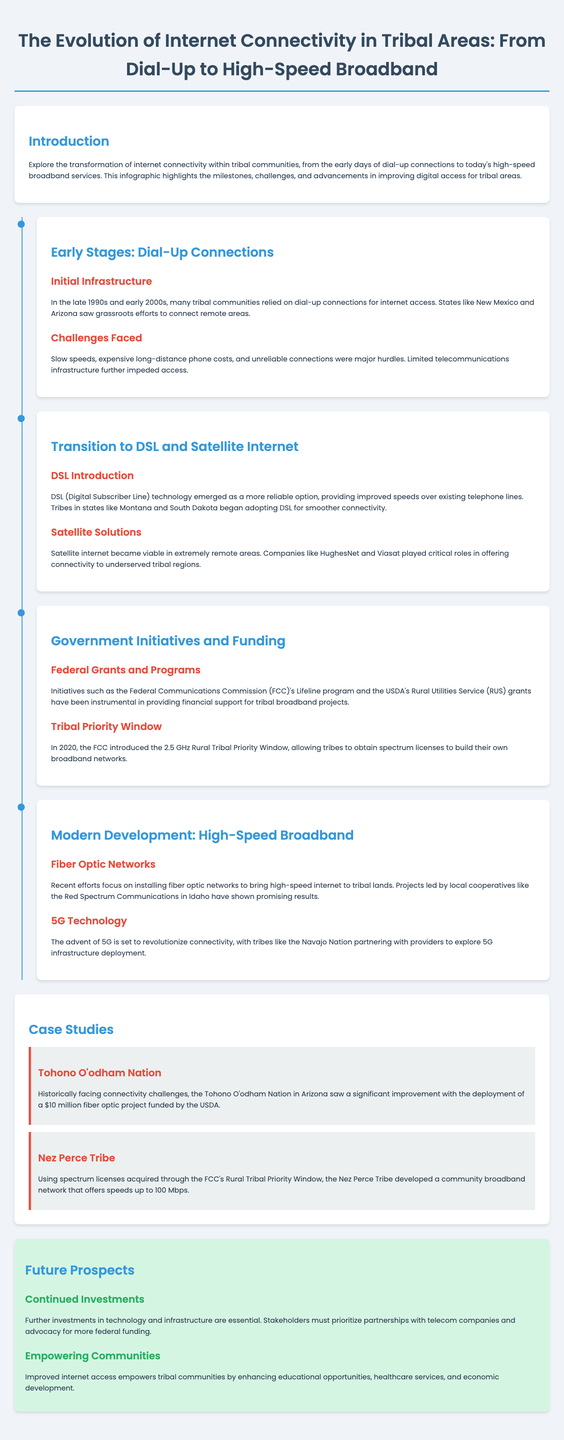What technology provided improved speeds over dial-up? The document mentions that DSL (Digital Subscriber Line) technology emerged as a more reliable option for improved speeds over existing telephone lines.
Answer: DSL Which tribal area experienced significant improvement with a $10 million fiber optic project? The Tohono O'odham Nation in Arizona is highlighted as having significant improvement from the deployment of a $10 million fiber optic project.
Answer: Tohono O'odham Nation What federal program provided financial support for tribal broadband projects? The FCC's Lifeline program is mentioned as an initiative that has been instrumental in providing financial support for tribal broadband projects.
Answer: Lifeline program What speed does the community broadband network created by the Nez Perce Tribe offer? The Nez Perce Tribe's community broadband network offers speeds up to 100 Mbps.
Answer: 100 Mbps What technological advancement is expected to revolutionize connectivity? The document states that the advent of 5G is set to revolutionize connectivity for tribal areas.
Answer: 5G What is essential for further improvements in internet access for tribal communities? Continued investments in technology and infrastructure are emphasized as essential for further improvements.
Answer: Continued investments What type of internet connection was commonly used in tribal areas in the late 1990s and early 2000s? The document indicates that many tribal communities relied on dial-up connections during that period.
Answer: Dial-up Which states saw grassroots efforts to connect remote areas in the early stages? The document mentions New Mexico and Arizona as states where grassroots efforts were made to connect remote areas.
Answer: New Mexico and Arizona What is a key future prospect highlighted for empowering tribal communities? Enhanced educational opportunities is mentioned as a key future prospect resulting from improved internet access.
Answer: Educational opportunities 